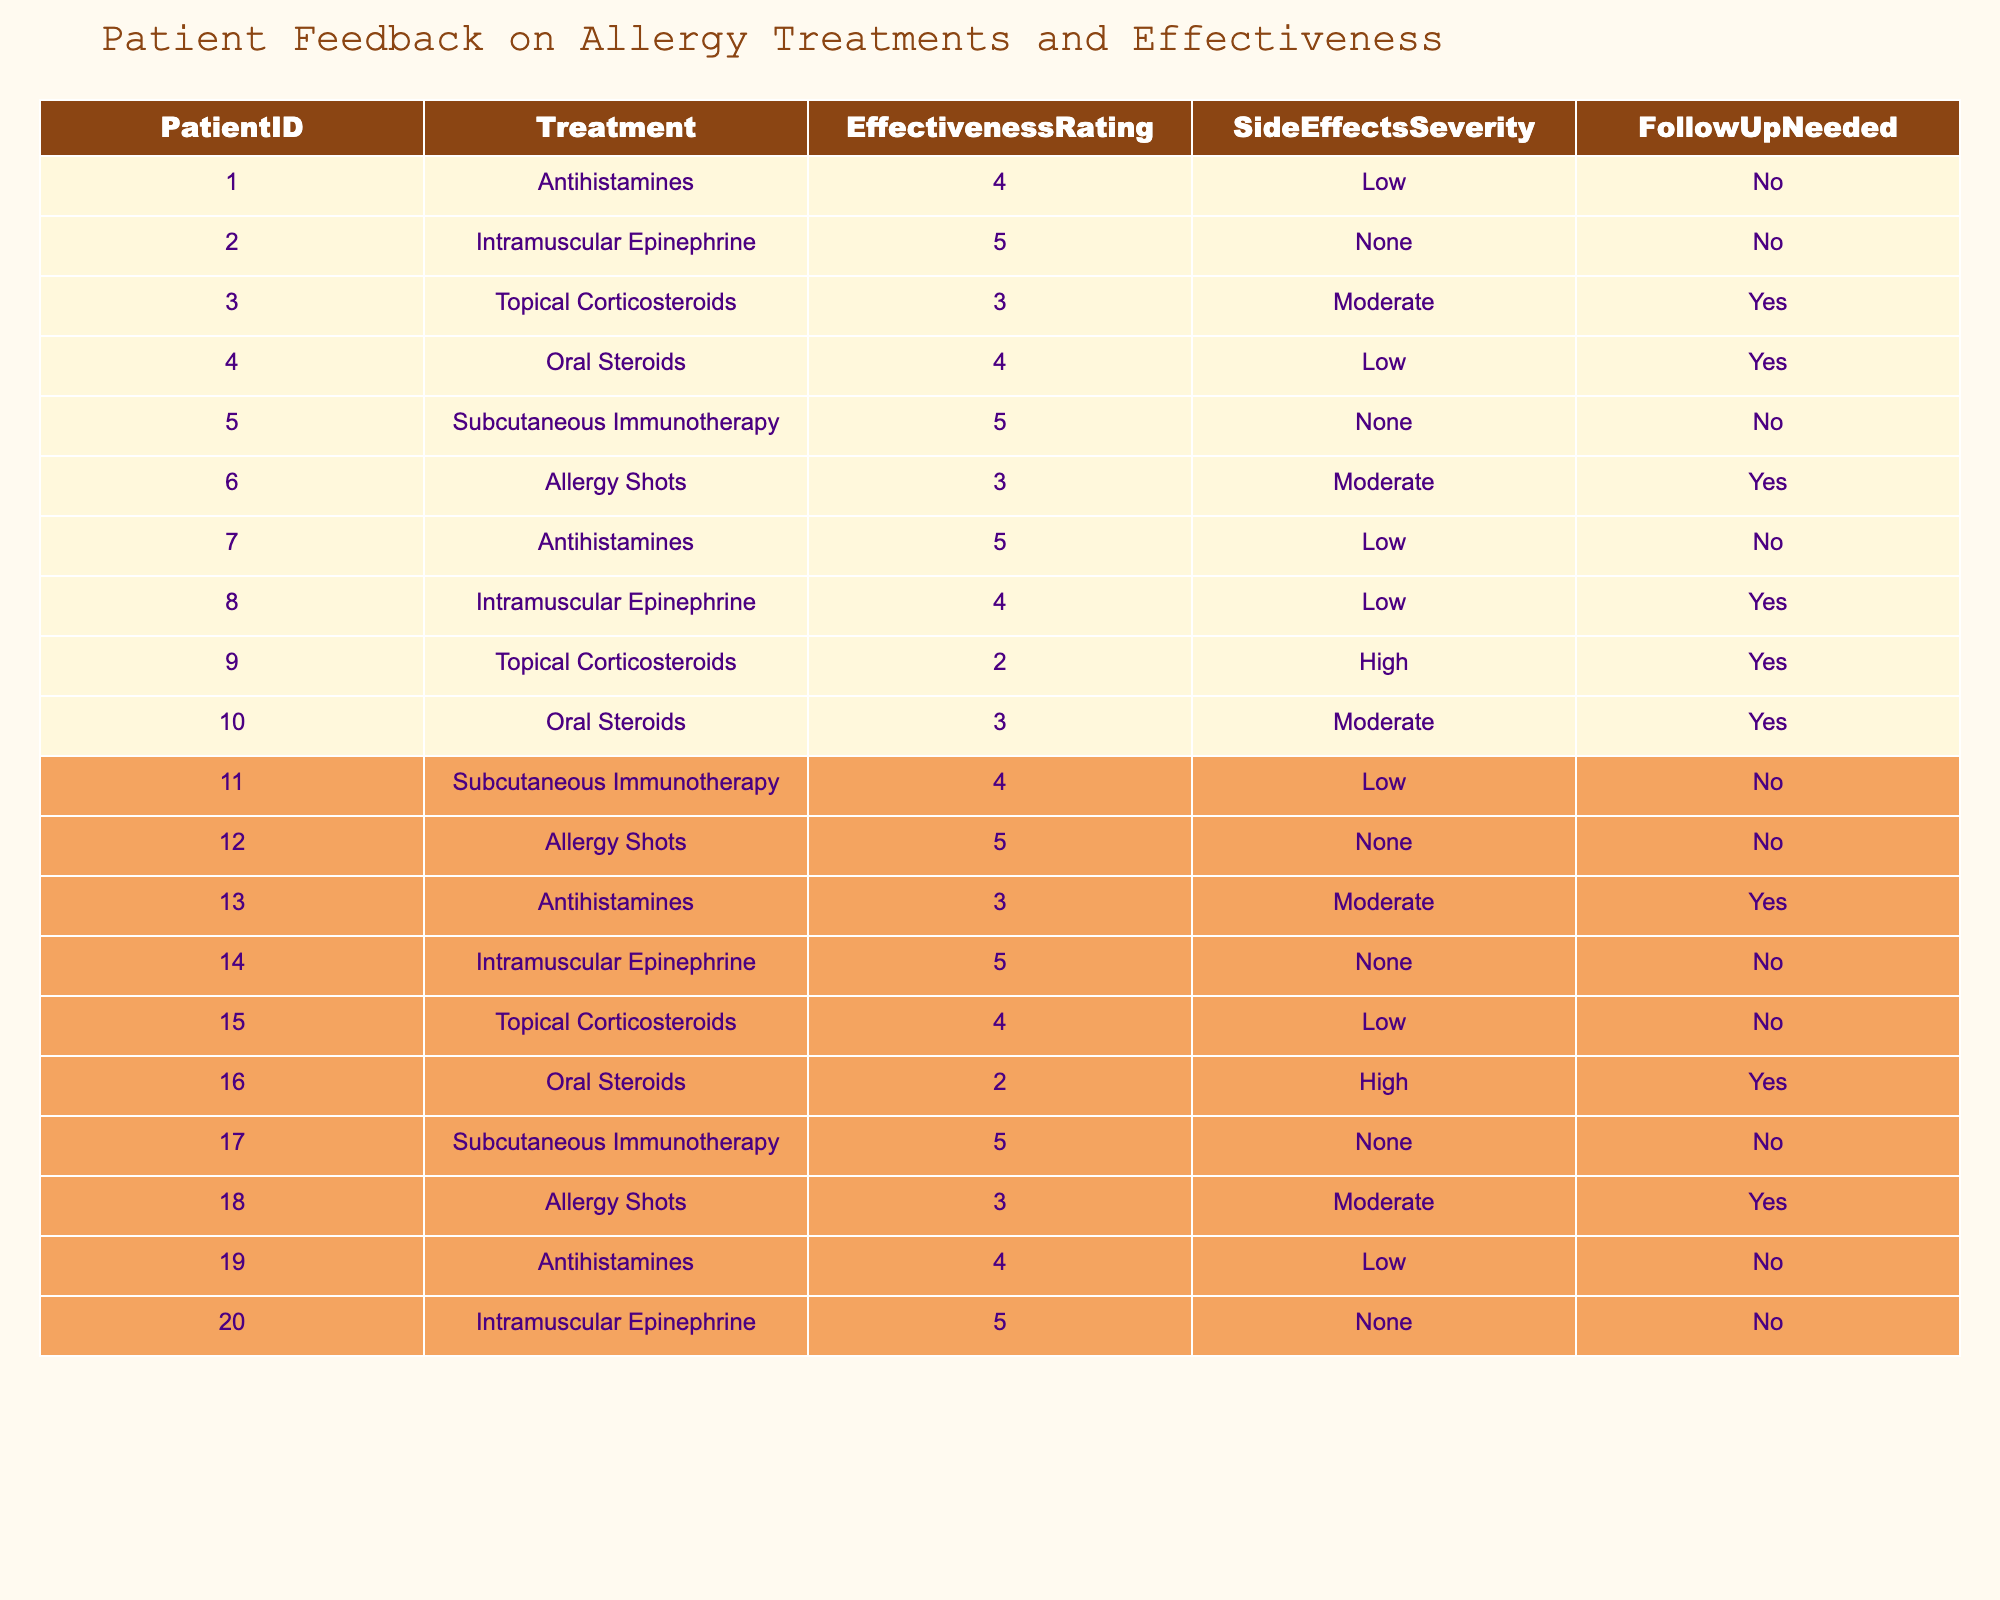What is the effectiveness rating of Subcutaneous Immunotherapy? To find the effectiveness rating for Subcutaneous Immunotherapy, look for the rows in the table that list this treatment. There are three entries for Subcutaneous Immunotherapy with ratings of 5, 4, and 5. The most a single patient rated it is 5.
Answer: 5 How many patients reported a need for follow-up after receiving Topical Corticosteroids? We look for all entries under the Treatment "Topical Corticosteroids" and then check the FollowUpNeeded column for each. There are three patients who received Topical Corticosteroids (PatientIDs 3, 9, and 15), among them, two patients need follow-up (Patients 3 and 9).
Answer: 2 What is the average effectiveness rating for Intramuscular Epinephrine? There are three patients who received Intramuscular Epinephrine (PatientIDs 2, 8, and 14). Their effectiveness ratings are 5, 4, and 5 respectively. The average effectiveness rating is calculated as (5 + 4 + 5) / 3 = 14 / 3, which approximates to 4.67.
Answer: 4.67 Do any patients report high side effects with Allergy Shots? Look at all entries for Allergy Shots and check their SideEffectsSeverity. There are four patients who received Allergy Shots (Patients 6, 12, and 18), and none of them reported high side effects; all ratings were either moderate or none.
Answer: No What is the most effective treatment reported and how many patients used it? The most effective treatment according to the table is Intramuscular Epinephrine and Subcutaneous Immunotherapy, both with an effectiveness rating of 5. Intramuscular Epinephrine was used by three patients (IDs 2, 8, and 14), while Subcutaneous Immunotherapy was used by three patients (IDs 5, 11, and 17). In total, 6 patients reported this maximum effectiveness rating.
Answer: 6 Which treatment has the lowest average effectiveness rating and what is that rating? The treatments are evaluated, and the ratings based on the entries in the table for each are assessed. The treatment with the lowest average effectiveness is Topical Corticosteroids with ratings of 3, 2, and 4 yielding an average of (3 + 2 + 4)/3 = 3.
Answer: 3 Is there any treatment with no reported side effects, and how many patients used it? To find treatments without side effects, we check the SideEffectsSeverity column for entries marked "None." Both Intramuscular Epinephrine and Subcutaneous Immunotherapy have no reported side effects. Each had three users; hence, a total of 6 patients experienced these treatments without side effects.
Answer: 6 Which treatment had the highest number of patients needing follow-up? By reviewing the FollowUpNeeded column, we tally how many patients indicated they required follow-up for each treatment. Allergy Shots have four patients indicating follow-up needed (Patients 6, 10, 18). Therefore, Allergy Shots had the highest number of follow-up requests.
Answer: Allergy Shots How many treatments are reported in total without any side effects? We check each treatment's entry for those marked "None" in the SideEffectsSeverity column. There are two treatments with no reported side effects: Intramuscular Epinephrine and Subcutaneous Immunotherapy.
Answer: 2 What percentage of patients rated Antihistamines as effective (4 or higher)? The effectiveness ratings for Antihistamines include three patients. Out of these, two rated it as 4 or higher (Patients 1 and 7). To calculate the percentage: (2/3) * 100 = 66.67%.
Answer: 66.67% 